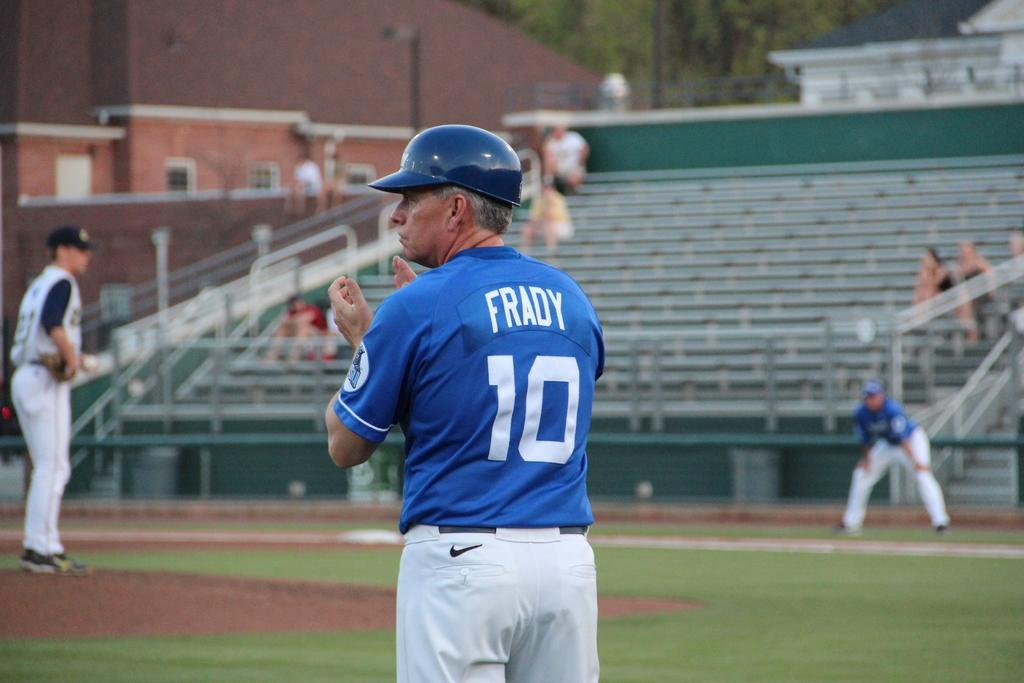Provide a one-sentence caption for the provided image. A baseball player wearing number ten and called Frady applauds as a sparse crowd watch. 